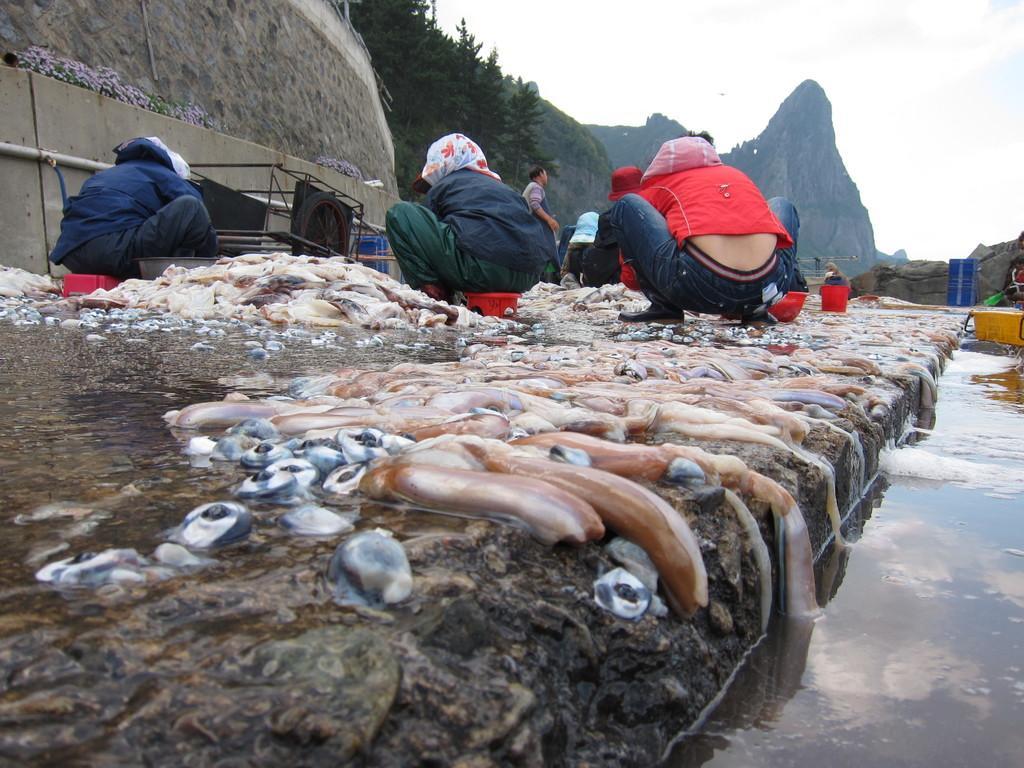Please provide a concise description of this image. In this picture there are group of people and there is a meat on the floor. At the back there is a mountain and there are trees. On the right side of the image there is water. At the top there is sky and there are clouds. 